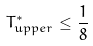<formula> <loc_0><loc_0><loc_500><loc_500>T ^ { * } _ { u p p e r } \leq \frac { 1 } { 8 }</formula> 